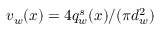Convert formula to latex. <formula><loc_0><loc_0><loc_500><loc_500>v _ { w } ( x ) = 4 q _ { w } ^ { s } ( x ) / ( \pi d _ { w } ^ { 2 } )</formula> 